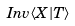<formula> <loc_0><loc_0><loc_500><loc_500>I n v \langle X | T \rangle</formula> 